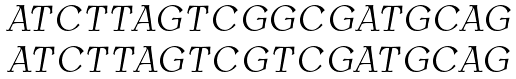Convert formula to latex. <formula><loc_0><loc_0><loc_500><loc_500>\begin{array} { c } A T C T T A G T C G G C G A T G C A G \\ A T C T T A G T C G T C G A T G C A G \end{array}</formula> 